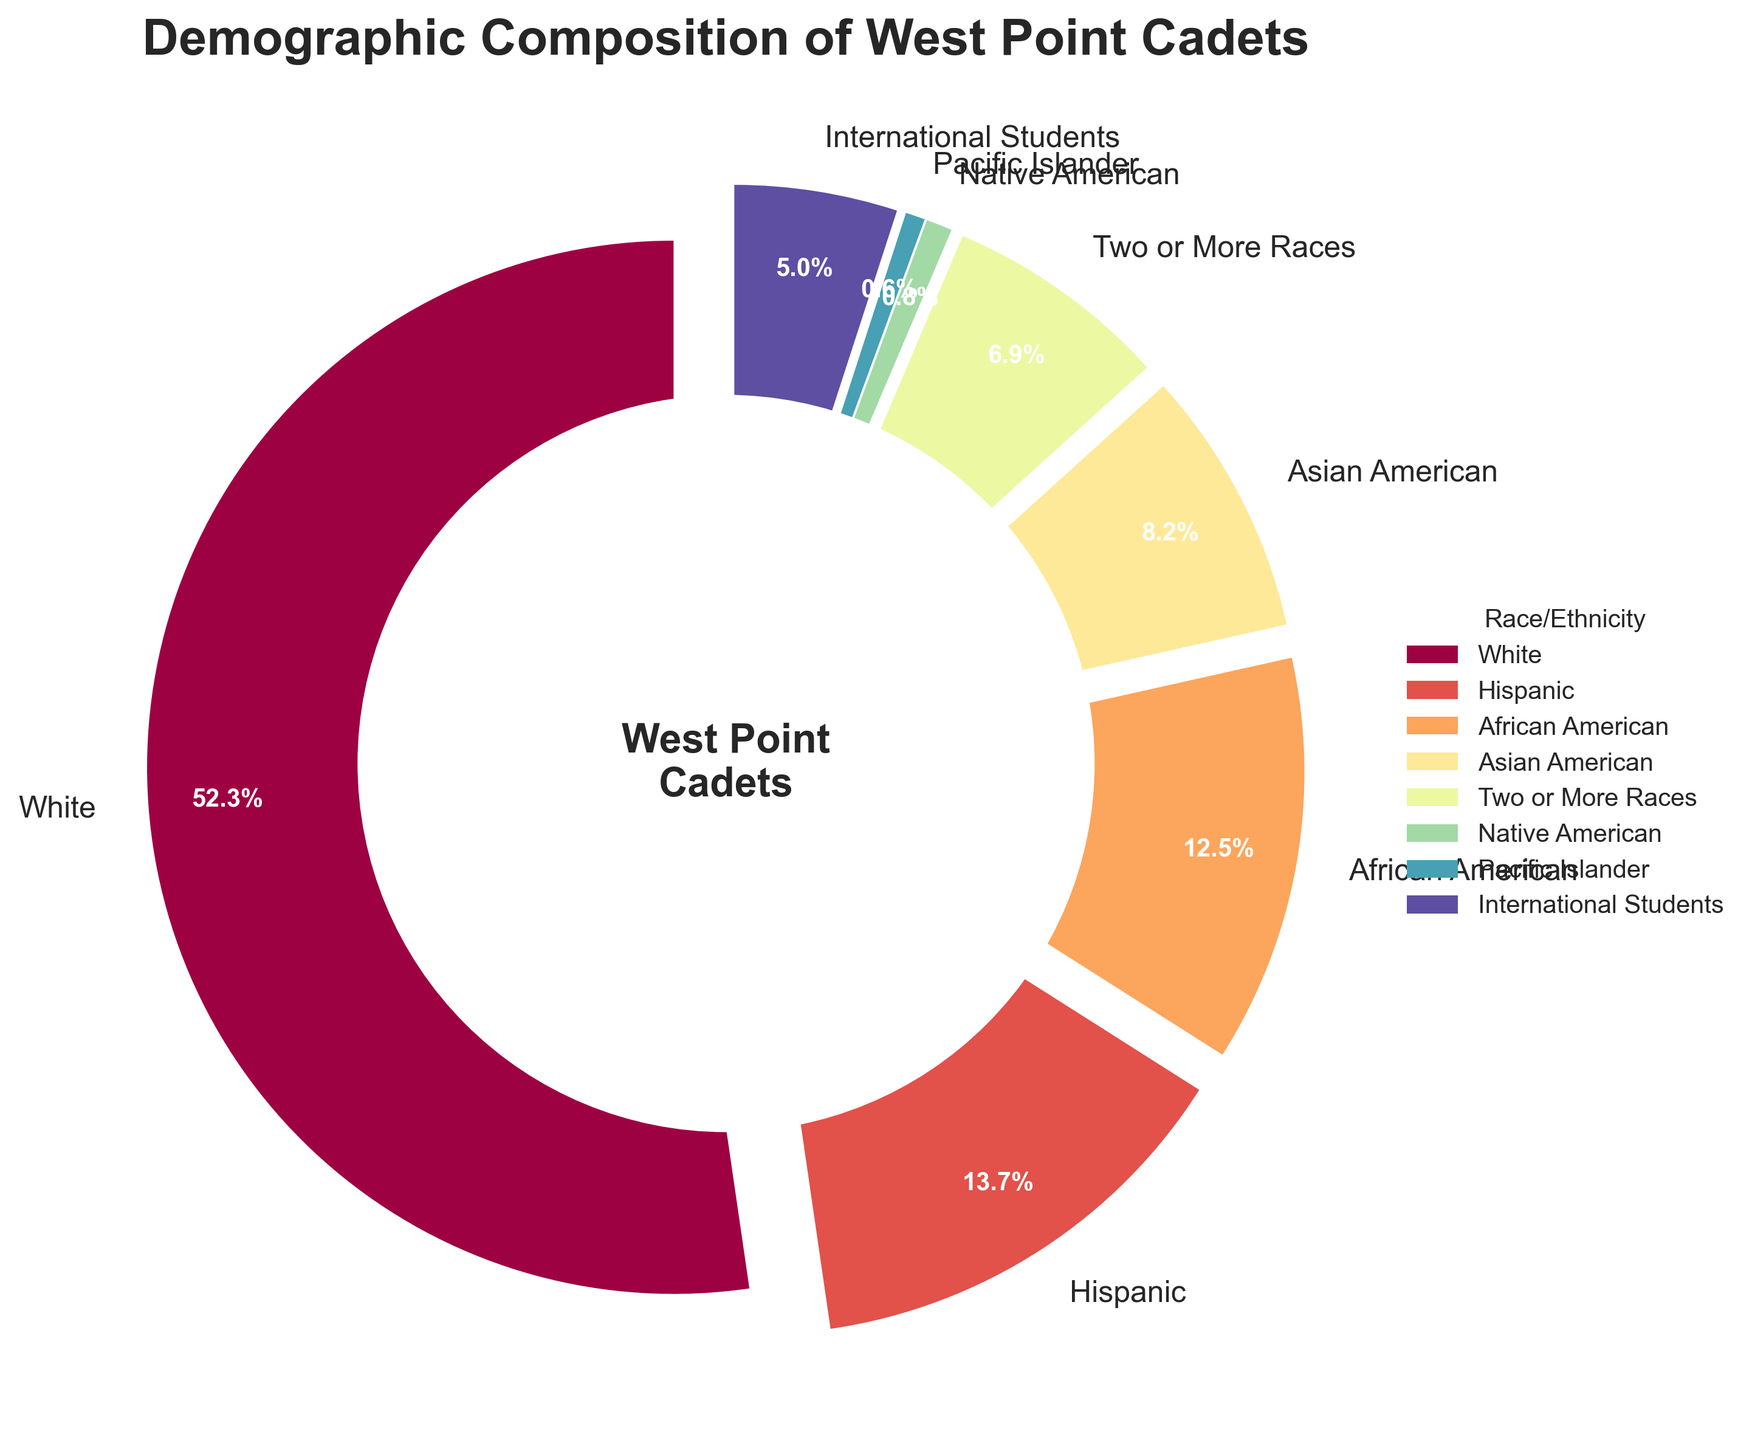What percentage of the cadet demographic is either Hispanic or Asian American? To find the combined percentage for Hispanic and Asian American cadets, we add their individual percentages: 13.7% (Hispanic) + 8.2% (Asian American) = 21.9%.
Answer: 21.9% Which demographic group has the lowest percentage of cadets, and what is that percentage? By examining the pie chart, the demographic group with the lowest percentage is Pacific Islander, which has a percentage of 0.6%.
Answer: Pacific Islander, 0.6% How much greater is the percentage of White cadets compared to the percentage of African American cadets? Subtract the percentage of African American cadets from the percentage of White cadets: 52.3% (White) - 12.5% (African American) = 39.8%.
Answer: 39.8% Which demographic groups together make up more than half of the cadet population, and what is their combined percentage? White cadets alone make up 52.3% of the population. Therefore, White cadets make up more than half of the cadet population on their own.
Answer: White, 52.3% What is the average percentage of cadets for the groups Asian American, Native American, and International Students? To find the average, add the percentages for these groups and divide by the number of groups: (8.2% + 0.8% + 5.0%) / 3 = 14% / 3 = 4.67%.
Answer: 4.67% Are there more Hispanic cadets or cadets identified as Two or More Races, and by how much? By looking at the chart, Hispanic cadets (13.7%) are more than cadets identified as Two or More Races (6.9%). The difference is 13.7% - 6.9% = 6.8%.
Answer: Hispanic, 6.8% Among the listed demographic groups, what is the median percentage, and which group does it represent? To find the median percentage, list all percentages in ascending order: 0.6%, 0.8%, 5.0%, 6.9%, 8.2%, 12.5%, 13.7%, 52.3%. The median is the average of the two middle numbers, (6.9% + 8.2%) / 2 = 15.1% / 2 = 7.55%, represented by neither of the two groups as it is an average of "Two or More Races" and "Asian American".
Answer: 7.55% What is the total percentage of cadets that do not fall into the White, Hispanic, or African American categories? First, find the combined percentage of White, Hispanic, and African American cadets: 52.3% + 13.7% + 12.5% = 78.5%. Then subtract from 100%: 100% - 78.5% = 21.5%.
Answer: 21.5% What is the sum of the percentages for Native American, Pacific Islander, and Two or More Races cadets? Add the percentages for these groups: 0.8% (Native American) + 0.6% (Pacific Islander) + 6.9% (Two or More Races) = 8.3%.
Answer: 8.3% 